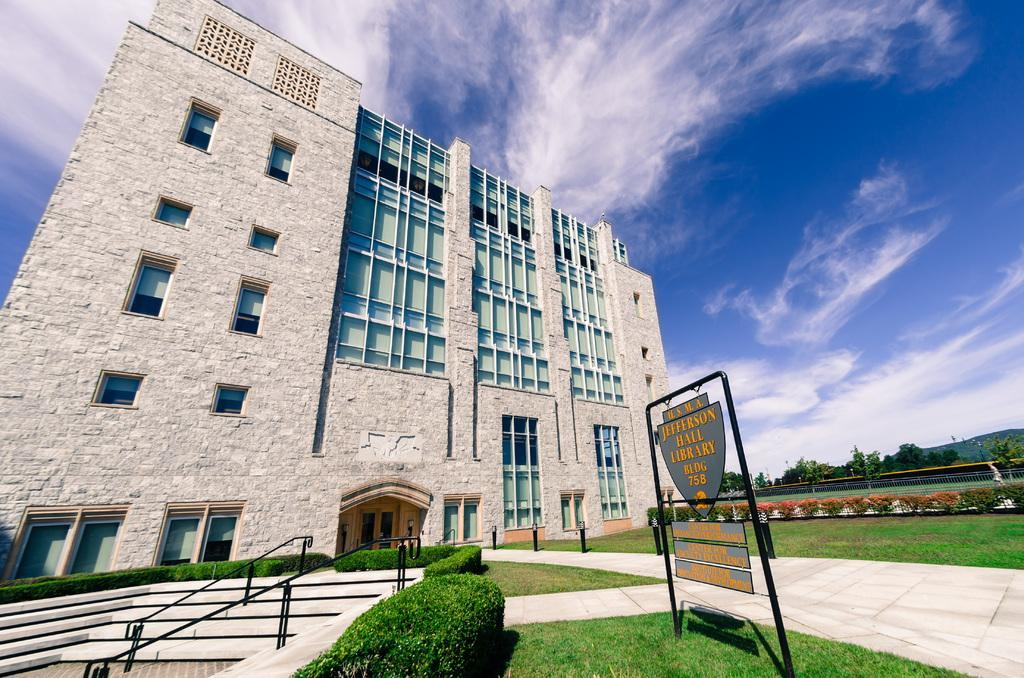What type of structure is present in the image? There is a building in the image. What type of vegetation can be seen in the image? There is grass and plants visible in the image. Are there any architectural features in the image? Yes, there are steps in the image. What is the purpose of the board with writing in the image? The purpose of the board with writing is not clear from the image, but it may be used for displaying information or announcements. What can be seen in the background of the image? There are trees and the sky visible in the background of the image. What type of gold transport can be seen in the image? There is no gold transport present in the image. Is there a pet visible in the image? There is no pet visible in the image. 